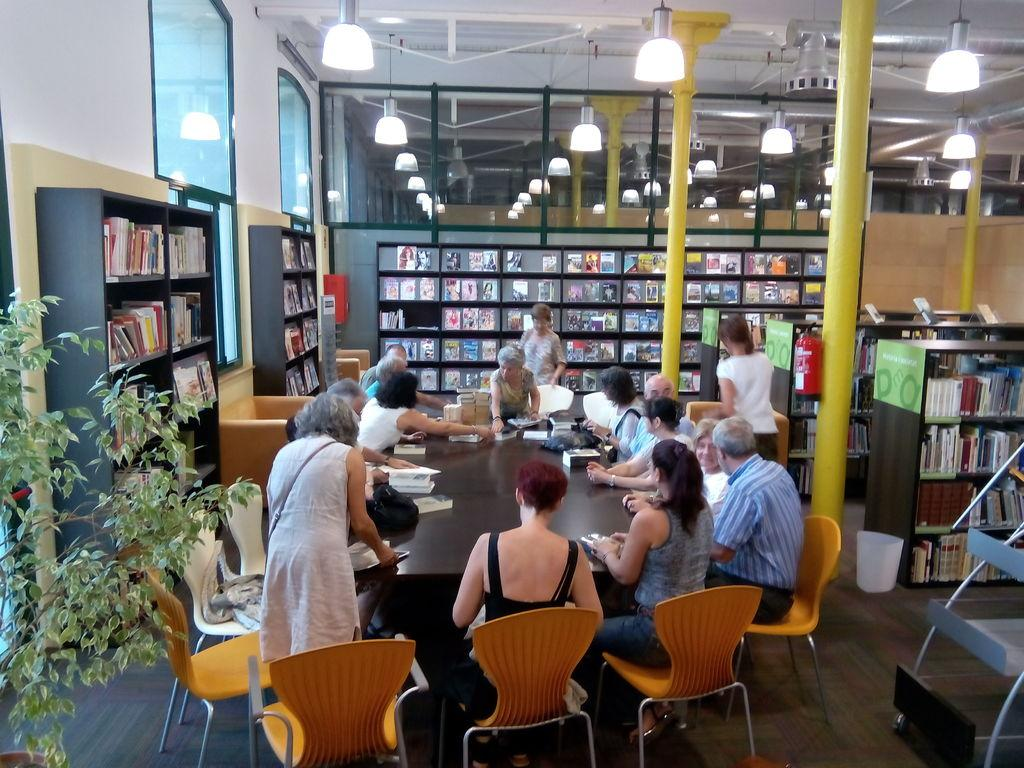What are the people around the table doing? The people around the table are holding books. What can be seen in the background of the image? There is a big bookshelf in the background. What is the purpose of the bookshelf? The bookshelf contains books. How many cars can be seen on the bookshelf in the image? There are no cars present in the image, as it features people holding books and a bookshelf containing books. 